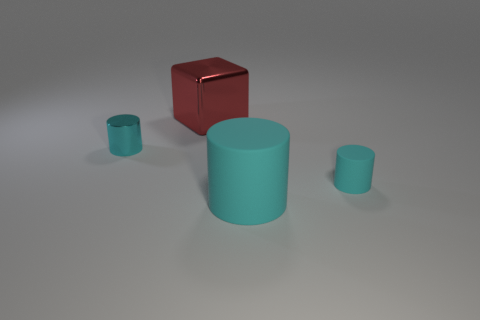Subtract all small cyan cylinders. How many cylinders are left? 1 Subtract 1 cylinders. How many cylinders are left? 2 Add 1 rubber balls. How many objects exist? 5 Subtract all cubes. How many objects are left? 3 Add 4 rubber cylinders. How many rubber cylinders are left? 6 Add 4 cyan metal cylinders. How many cyan metal cylinders exist? 5 Subtract 3 cyan cylinders. How many objects are left? 1 Subtract all large shiny things. Subtract all red shiny cubes. How many objects are left? 2 